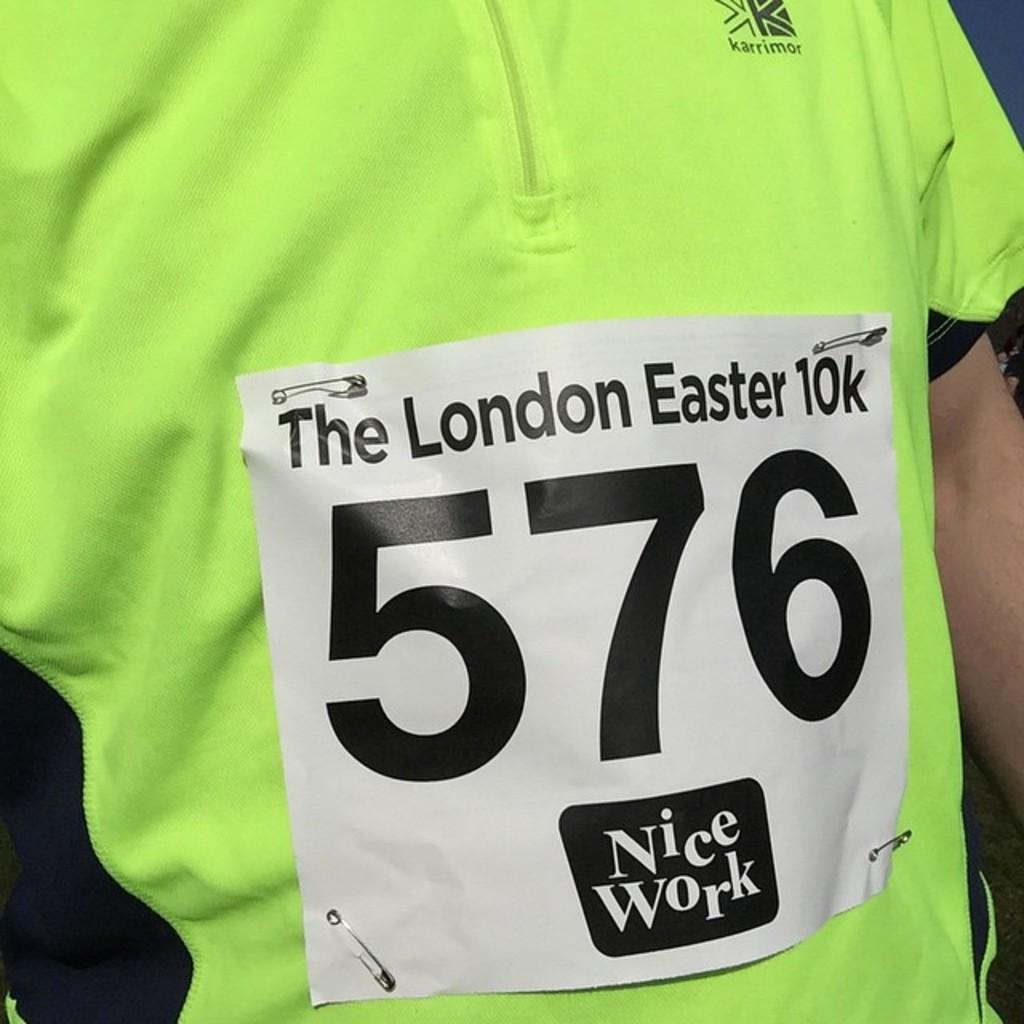<image>
Write a terse but informative summary of the picture. Man wearing a sign on his shirt which says 576. 